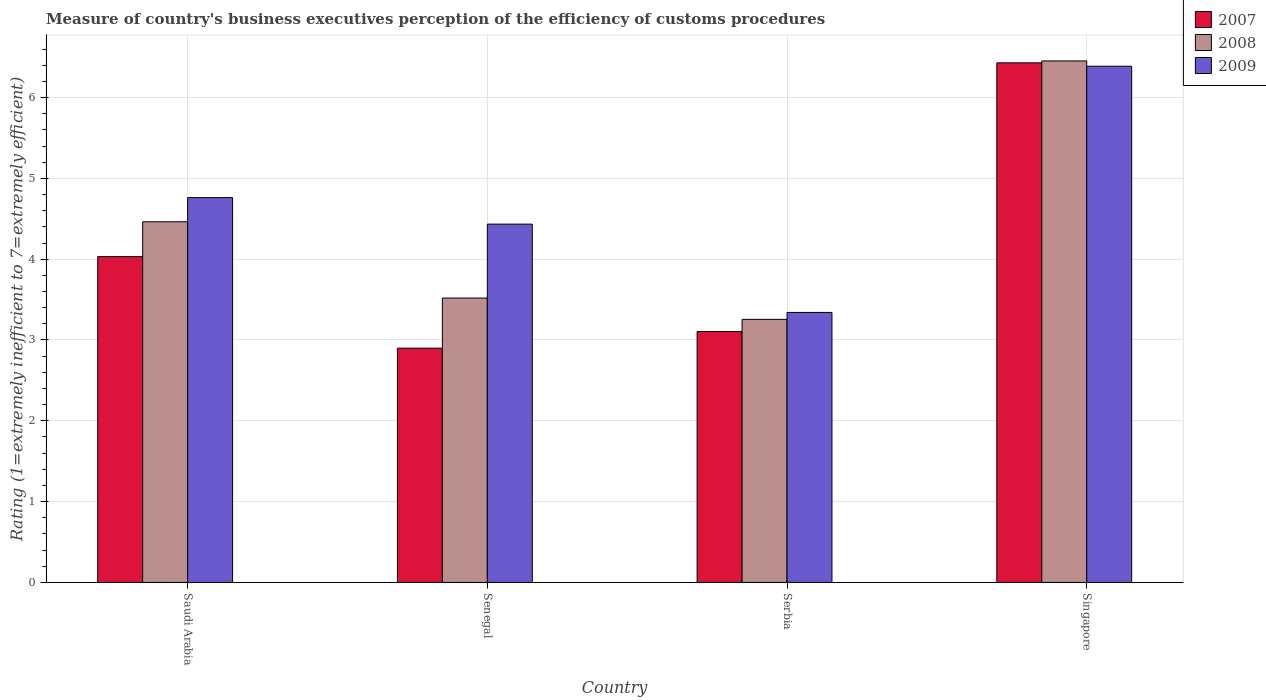How many different coloured bars are there?
Provide a short and direct response. 3. Are the number of bars per tick equal to the number of legend labels?
Offer a terse response. Yes. How many bars are there on the 3rd tick from the left?
Your answer should be compact. 3. What is the label of the 4th group of bars from the left?
Keep it short and to the point. Singapore. What is the rating of the efficiency of customs procedure in 2009 in Saudi Arabia?
Give a very brief answer. 4.76. Across all countries, what is the maximum rating of the efficiency of customs procedure in 2007?
Keep it short and to the point. 6.43. Across all countries, what is the minimum rating of the efficiency of customs procedure in 2009?
Give a very brief answer. 3.34. In which country was the rating of the efficiency of customs procedure in 2008 maximum?
Offer a very short reply. Singapore. In which country was the rating of the efficiency of customs procedure in 2009 minimum?
Ensure brevity in your answer.  Serbia. What is the total rating of the efficiency of customs procedure in 2007 in the graph?
Offer a very short reply. 16.47. What is the difference between the rating of the efficiency of customs procedure in 2008 in Senegal and that in Singapore?
Give a very brief answer. -2.93. What is the difference between the rating of the efficiency of customs procedure in 2009 in Saudi Arabia and the rating of the efficiency of customs procedure in 2008 in Singapore?
Keep it short and to the point. -1.69. What is the average rating of the efficiency of customs procedure in 2008 per country?
Give a very brief answer. 4.42. What is the difference between the rating of the efficiency of customs procedure of/in 2007 and rating of the efficiency of customs procedure of/in 2009 in Singapore?
Give a very brief answer. 0.04. In how many countries, is the rating of the efficiency of customs procedure in 2007 greater than 2.2?
Ensure brevity in your answer.  4. What is the ratio of the rating of the efficiency of customs procedure in 2009 in Saudi Arabia to that in Senegal?
Your answer should be compact. 1.07. What is the difference between the highest and the second highest rating of the efficiency of customs procedure in 2007?
Provide a short and direct response. -0.93. What is the difference between the highest and the lowest rating of the efficiency of customs procedure in 2008?
Provide a succinct answer. 3.2. In how many countries, is the rating of the efficiency of customs procedure in 2007 greater than the average rating of the efficiency of customs procedure in 2007 taken over all countries?
Your answer should be very brief. 1. Is the sum of the rating of the efficiency of customs procedure in 2007 in Senegal and Singapore greater than the maximum rating of the efficiency of customs procedure in 2009 across all countries?
Your answer should be compact. Yes. What does the 3rd bar from the left in Saudi Arabia represents?
Ensure brevity in your answer.  2009. How many countries are there in the graph?
Make the answer very short. 4. Does the graph contain any zero values?
Ensure brevity in your answer.  No. Where does the legend appear in the graph?
Provide a short and direct response. Top right. What is the title of the graph?
Your response must be concise. Measure of country's business executives perception of the efficiency of customs procedures. What is the label or title of the X-axis?
Make the answer very short. Country. What is the label or title of the Y-axis?
Provide a succinct answer. Rating (1=extremely inefficient to 7=extremely efficient). What is the Rating (1=extremely inefficient to 7=extremely efficient) in 2007 in Saudi Arabia?
Your answer should be very brief. 4.03. What is the Rating (1=extremely inefficient to 7=extremely efficient) of 2008 in Saudi Arabia?
Your answer should be compact. 4.46. What is the Rating (1=extremely inefficient to 7=extremely efficient) of 2009 in Saudi Arabia?
Make the answer very short. 4.76. What is the Rating (1=extremely inefficient to 7=extremely efficient) of 2007 in Senegal?
Provide a succinct answer. 2.9. What is the Rating (1=extremely inefficient to 7=extremely efficient) in 2008 in Senegal?
Your answer should be compact. 3.52. What is the Rating (1=extremely inefficient to 7=extremely efficient) of 2009 in Senegal?
Offer a very short reply. 4.43. What is the Rating (1=extremely inefficient to 7=extremely efficient) in 2007 in Serbia?
Your answer should be compact. 3.1. What is the Rating (1=extremely inefficient to 7=extremely efficient) of 2008 in Serbia?
Keep it short and to the point. 3.26. What is the Rating (1=extremely inefficient to 7=extremely efficient) in 2009 in Serbia?
Your answer should be compact. 3.34. What is the Rating (1=extremely inefficient to 7=extremely efficient) in 2007 in Singapore?
Provide a succinct answer. 6.43. What is the Rating (1=extremely inefficient to 7=extremely efficient) of 2008 in Singapore?
Offer a very short reply. 6.45. What is the Rating (1=extremely inefficient to 7=extremely efficient) of 2009 in Singapore?
Provide a short and direct response. 6.39. Across all countries, what is the maximum Rating (1=extremely inefficient to 7=extremely efficient) of 2007?
Ensure brevity in your answer.  6.43. Across all countries, what is the maximum Rating (1=extremely inefficient to 7=extremely efficient) of 2008?
Your answer should be very brief. 6.45. Across all countries, what is the maximum Rating (1=extremely inefficient to 7=extremely efficient) in 2009?
Offer a very short reply. 6.39. Across all countries, what is the minimum Rating (1=extremely inefficient to 7=extremely efficient) of 2007?
Keep it short and to the point. 2.9. Across all countries, what is the minimum Rating (1=extremely inefficient to 7=extremely efficient) of 2008?
Give a very brief answer. 3.26. Across all countries, what is the minimum Rating (1=extremely inefficient to 7=extremely efficient) in 2009?
Give a very brief answer. 3.34. What is the total Rating (1=extremely inefficient to 7=extremely efficient) in 2007 in the graph?
Give a very brief answer. 16.47. What is the total Rating (1=extremely inefficient to 7=extremely efficient) of 2008 in the graph?
Your answer should be compact. 17.69. What is the total Rating (1=extremely inefficient to 7=extremely efficient) in 2009 in the graph?
Keep it short and to the point. 18.92. What is the difference between the Rating (1=extremely inefficient to 7=extremely efficient) of 2007 in Saudi Arabia and that in Senegal?
Keep it short and to the point. 1.13. What is the difference between the Rating (1=extremely inefficient to 7=extremely efficient) in 2008 in Saudi Arabia and that in Senegal?
Keep it short and to the point. 0.94. What is the difference between the Rating (1=extremely inefficient to 7=extremely efficient) in 2009 in Saudi Arabia and that in Senegal?
Offer a very short reply. 0.33. What is the difference between the Rating (1=extremely inefficient to 7=extremely efficient) of 2007 in Saudi Arabia and that in Serbia?
Your answer should be compact. 0.93. What is the difference between the Rating (1=extremely inefficient to 7=extremely efficient) in 2008 in Saudi Arabia and that in Serbia?
Make the answer very short. 1.21. What is the difference between the Rating (1=extremely inefficient to 7=extremely efficient) of 2009 in Saudi Arabia and that in Serbia?
Provide a short and direct response. 1.42. What is the difference between the Rating (1=extremely inefficient to 7=extremely efficient) of 2007 in Saudi Arabia and that in Singapore?
Give a very brief answer. -2.4. What is the difference between the Rating (1=extremely inefficient to 7=extremely efficient) of 2008 in Saudi Arabia and that in Singapore?
Ensure brevity in your answer.  -1.99. What is the difference between the Rating (1=extremely inefficient to 7=extremely efficient) of 2009 in Saudi Arabia and that in Singapore?
Your answer should be compact. -1.63. What is the difference between the Rating (1=extremely inefficient to 7=extremely efficient) of 2007 in Senegal and that in Serbia?
Your answer should be compact. -0.21. What is the difference between the Rating (1=extremely inefficient to 7=extremely efficient) of 2008 in Senegal and that in Serbia?
Your response must be concise. 0.26. What is the difference between the Rating (1=extremely inefficient to 7=extremely efficient) in 2009 in Senegal and that in Serbia?
Offer a very short reply. 1.09. What is the difference between the Rating (1=extremely inefficient to 7=extremely efficient) of 2007 in Senegal and that in Singapore?
Your answer should be very brief. -3.53. What is the difference between the Rating (1=extremely inefficient to 7=extremely efficient) in 2008 in Senegal and that in Singapore?
Keep it short and to the point. -2.93. What is the difference between the Rating (1=extremely inefficient to 7=extremely efficient) in 2009 in Senegal and that in Singapore?
Give a very brief answer. -1.95. What is the difference between the Rating (1=extremely inefficient to 7=extremely efficient) in 2007 in Serbia and that in Singapore?
Make the answer very short. -3.33. What is the difference between the Rating (1=extremely inefficient to 7=extremely efficient) of 2008 in Serbia and that in Singapore?
Your answer should be compact. -3.2. What is the difference between the Rating (1=extremely inefficient to 7=extremely efficient) of 2009 in Serbia and that in Singapore?
Keep it short and to the point. -3.05. What is the difference between the Rating (1=extremely inefficient to 7=extremely efficient) of 2007 in Saudi Arabia and the Rating (1=extremely inefficient to 7=extremely efficient) of 2008 in Senegal?
Your answer should be compact. 0.51. What is the difference between the Rating (1=extremely inefficient to 7=extremely efficient) in 2007 in Saudi Arabia and the Rating (1=extremely inefficient to 7=extremely efficient) in 2009 in Senegal?
Ensure brevity in your answer.  -0.4. What is the difference between the Rating (1=extremely inefficient to 7=extremely efficient) of 2008 in Saudi Arabia and the Rating (1=extremely inefficient to 7=extremely efficient) of 2009 in Senegal?
Your answer should be compact. 0.03. What is the difference between the Rating (1=extremely inefficient to 7=extremely efficient) in 2007 in Saudi Arabia and the Rating (1=extremely inefficient to 7=extremely efficient) in 2008 in Serbia?
Keep it short and to the point. 0.78. What is the difference between the Rating (1=extremely inefficient to 7=extremely efficient) in 2007 in Saudi Arabia and the Rating (1=extremely inefficient to 7=extremely efficient) in 2009 in Serbia?
Your answer should be very brief. 0.69. What is the difference between the Rating (1=extremely inefficient to 7=extremely efficient) of 2008 in Saudi Arabia and the Rating (1=extremely inefficient to 7=extremely efficient) of 2009 in Serbia?
Offer a very short reply. 1.12. What is the difference between the Rating (1=extremely inefficient to 7=extremely efficient) of 2007 in Saudi Arabia and the Rating (1=extremely inefficient to 7=extremely efficient) of 2008 in Singapore?
Your answer should be very brief. -2.42. What is the difference between the Rating (1=extremely inefficient to 7=extremely efficient) in 2007 in Saudi Arabia and the Rating (1=extremely inefficient to 7=extremely efficient) in 2009 in Singapore?
Ensure brevity in your answer.  -2.36. What is the difference between the Rating (1=extremely inefficient to 7=extremely efficient) of 2008 in Saudi Arabia and the Rating (1=extremely inefficient to 7=extremely efficient) of 2009 in Singapore?
Give a very brief answer. -1.92. What is the difference between the Rating (1=extremely inefficient to 7=extremely efficient) in 2007 in Senegal and the Rating (1=extremely inefficient to 7=extremely efficient) in 2008 in Serbia?
Offer a very short reply. -0.36. What is the difference between the Rating (1=extremely inefficient to 7=extremely efficient) in 2007 in Senegal and the Rating (1=extremely inefficient to 7=extremely efficient) in 2009 in Serbia?
Provide a succinct answer. -0.44. What is the difference between the Rating (1=extremely inefficient to 7=extremely efficient) in 2008 in Senegal and the Rating (1=extremely inefficient to 7=extremely efficient) in 2009 in Serbia?
Make the answer very short. 0.18. What is the difference between the Rating (1=extremely inefficient to 7=extremely efficient) in 2007 in Senegal and the Rating (1=extremely inefficient to 7=extremely efficient) in 2008 in Singapore?
Make the answer very short. -3.55. What is the difference between the Rating (1=extremely inefficient to 7=extremely efficient) of 2007 in Senegal and the Rating (1=extremely inefficient to 7=extremely efficient) of 2009 in Singapore?
Ensure brevity in your answer.  -3.49. What is the difference between the Rating (1=extremely inefficient to 7=extremely efficient) in 2008 in Senegal and the Rating (1=extremely inefficient to 7=extremely efficient) in 2009 in Singapore?
Give a very brief answer. -2.87. What is the difference between the Rating (1=extremely inefficient to 7=extremely efficient) in 2007 in Serbia and the Rating (1=extremely inefficient to 7=extremely efficient) in 2008 in Singapore?
Make the answer very short. -3.35. What is the difference between the Rating (1=extremely inefficient to 7=extremely efficient) in 2007 in Serbia and the Rating (1=extremely inefficient to 7=extremely efficient) in 2009 in Singapore?
Provide a succinct answer. -3.28. What is the difference between the Rating (1=extremely inefficient to 7=extremely efficient) in 2008 in Serbia and the Rating (1=extremely inefficient to 7=extremely efficient) in 2009 in Singapore?
Keep it short and to the point. -3.13. What is the average Rating (1=extremely inefficient to 7=extremely efficient) in 2007 per country?
Provide a short and direct response. 4.12. What is the average Rating (1=extremely inefficient to 7=extremely efficient) of 2008 per country?
Keep it short and to the point. 4.42. What is the average Rating (1=extremely inefficient to 7=extremely efficient) of 2009 per country?
Your answer should be compact. 4.73. What is the difference between the Rating (1=extremely inefficient to 7=extremely efficient) in 2007 and Rating (1=extremely inefficient to 7=extremely efficient) in 2008 in Saudi Arabia?
Your answer should be very brief. -0.43. What is the difference between the Rating (1=extremely inefficient to 7=extremely efficient) in 2007 and Rating (1=extremely inefficient to 7=extremely efficient) in 2009 in Saudi Arabia?
Offer a terse response. -0.73. What is the difference between the Rating (1=extremely inefficient to 7=extremely efficient) of 2008 and Rating (1=extremely inefficient to 7=extremely efficient) of 2009 in Saudi Arabia?
Offer a terse response. -0.3. What is the difference between the Rating (1=extremely inefficient to 7=extremely efficient) in 2007 and Rating (1=extremely inefficient to 7=extremely efficient) in 2008 in Senegal?
Keep it short and to the point. -0.62. What is the difference between the Rating (1=extremely inefficient to 7=extremely efficient) of 2007 and Rating (1=extremely inefficient to 7=extremely efficient) of 2009 in Senegal?
Your answer should be compact. -1.53. What is the difference between the Rating (1=extremely inefficient to 7=extremely efficient) in 2008 and Rating (1=extremely inefficient to 7=extremely efficient) in 2009 in Senegal?
Ensure brevity in your answer.  -0.91. What is the difference between the Rating (1=extremely inefficient to 7=extremely efficient) in 2007 and Rating (1=extremely inefficient to 7=extremely efficient) in 2008 in Serbia?
Offer a very short reply. -0.15. What is the difference between the Rating (1=extremely inefficient to 7=extremely efficient) in 2007 and Rating (1=extremely inefficient to 7=extremely efficient) in 2009 in Serbia?
Provide a succinct answer. -0.24. What is the difference between the Rating (1=extremely inefficient to 7=extremely efficient) of 2008 and Rating (1=extremely inefficient to 7=extremely efficient) of 2009 in Serbia?
Provide a short and direct response. -0.09. What is the difference between the Rating (1=extremely inefficient to 7=extremely efficient) of 2007 and Rating (1=extremely inefficient to 7=extremely efficient) of 2008 in Singapore?
Keep it short and to the point. -0.02. What is the difference between the Rating (1=extremely inefficient to 7=extremely efficient) of 2007 and Rating (1=extremely inefficient to 7=extremely efficient) of 2009 in Singapore?
Ensure brevity in your answer.  0.04. What is the difference between the Rating (1=extremely inefficient to 7=extremely efficient) of 2008 and Rating (1=extremely inefficient to 7=extremely efficient) of 2009 in Singapore?
Your answer should be very brief. 0.07. What is the ratio of the Rating (1=extremely inefficient to 7=extremely efficient) of 2007 in Saudi Arabia to that in Senegal?
Provide a succinct answer. 1.39. What is the ratio of the Rating (1=extremely inefficient to 7=extremely efficient) of 2008 in Saudi Arabia to that in Senegal?
Offer a very short reply. 1.27. What is the ratio of the Rating (1=extremely inefficient to 7=extremely efficient) in 2009 in Saudi Arabia to that in Senegal?
Provide a short and direct response. 1.07. What is the ratio of the Rating (1=extremely inefficient to 7=extremely efficient) of 2007 in Saudi Arabia to that in Serbia?
Give a very brief answer. 1.3. What is the ratio of the Rating (1=extremely inefficient to 7=extremely efficient) of 2008 in Saudi Arabia to that in Serbia?
Offer a very short reply. 1.37. What is the ratio of the Rating (1=extremely inefficient to 7=extremely efficient) of 2009 in Saudi Arabia to that in Serbia?
Provide a succinct answer. 1.43. What is the ratio of the Rating (1=extremely inefficient to 7=extremely efficient) in 2007 in Saudi Arabia to that in Singapore?
Offer a terse response. 0.63. What is the ratio of the Rating (1=extremely inefficient to 7=extremely efficient) of 2008 in Saudi Arabia to that in Singapore?
Offer a very short reply. 0.69. What is the ratio of the Rating (1=extremely inefficient to 7=extremely efficient) of 2009 in Saudi Arabia to that in Singapore?
Your response must be concise. 0.75. What is the ratio of the Rating (1=extremely inefficient to 7=extremely efficient) of 2007 in Senegal to that in Serbia?
Provide a succinct answer. 0.93. What is the ratio of the Rating (1=extremely inefficient to 7=extremely efficient) of 2008 in Senegal to that in Serbia?
Provide a short and direct response. 1.08. What is the ratio of the Rating (1=extremely inefficient to 7=extremely efficient) in 2009 in Senegal to that in Serbia?
Ensure brevity in your answer.  1.33. What is the ratio of the Rating (1=extremely inefficient to 7=extremely efficient) of 2007 in Senegal to that in Singapore?
Provide a short and direct response. 0.45. What is the ratio of the Rating (1=extremely inefficient to 7=extremely efficient) in 2008 in Senegal to that in Singapore?
Give a very brief answer. 0.55. What is the ratio of the Rating (1=extremely inefficient to 7=extremely efficient) of 2009 in Senegal to that in Singapore?
Make the answer very short. 0.69. What is the ratio of the Rating (1=extremely inefficient to 7=extremely efficient) in 2007 in Serbia to that in Singapore?
Your response must be concise. 0.48. What is the ratio of the Rating (1=extremely inefficient to 7=extremely efficient) in 2008 in Serbia to that in Singapore?
Your answer should be very brief. 0.5. What is the ratio of the Rating (1=extremely inefficient to 7=extremely efficient) of 2009 in Serbia to that in Singapore?
Your answer should be compact. 0.52. What is the difference between the highest and the second highest Rating (1=extremely inefficient to 7=extremely efficient) of 2007?
Provide a succinct answer. 2.4. What is the difference between the highest and the second highest Rating (1=extremely inefficient to 7=extremely efficient) of 2008?
Your response must be concise. 1.99. What is the difference between the highest and the second highest Rating (1=extremely inefficient to 7=extremely efficient) of 2009?
Provide a succinct answer. 1.63. What is the difference between the highest and the lowest Rating (1=extremely inefficient to 7=extremely efficient) in 2007?
Your answer should be compact. 3.53. What is the difference between the highest and the lowest Rating (1=extremely inefficient to 7=extremely efficient) in 2008?
Give a very brief answer. 3.2. What is the difference between the highest and the lowest Rating (1=extremely inefficient to 7=extremely efficient) in 2009?
Provide a succinct answer. 3.05. 